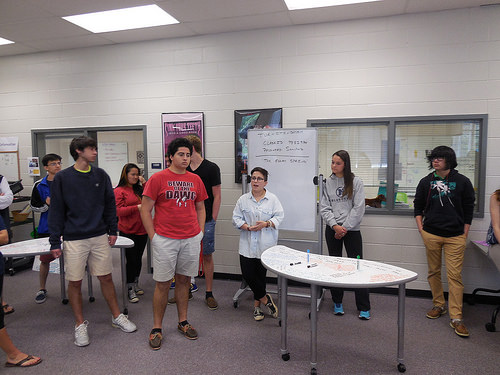<image>
Can you confirm if the boy is on the floor? Yes. Looking at the image, I can see the boy is positioned on top of the floor, with the floor providing support. Where is the man in relation to the table? Is it on the table? No. The man is not positioned on the table. They may be near each other, but the man is not supported by or resting on top of the table. 